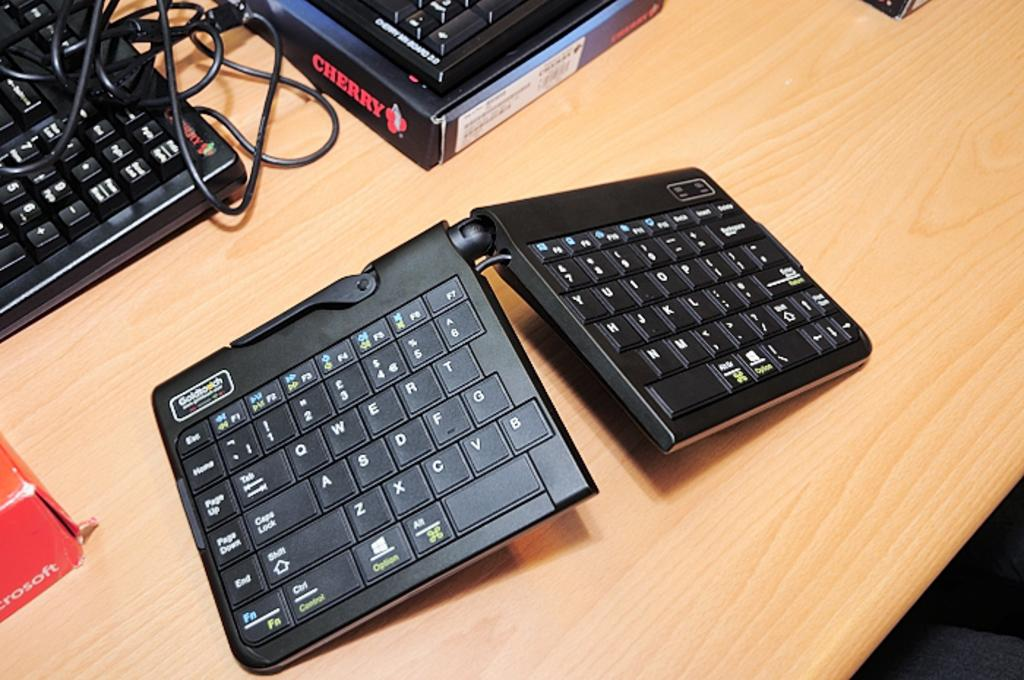What is the main object in the image? There is a keyboard in the image. Where is the keyboard located? The keyboard is on a table. Are there any cacti visible on the island in the image? There is no island or cactus present in the image; it features a keyboard on a table. 